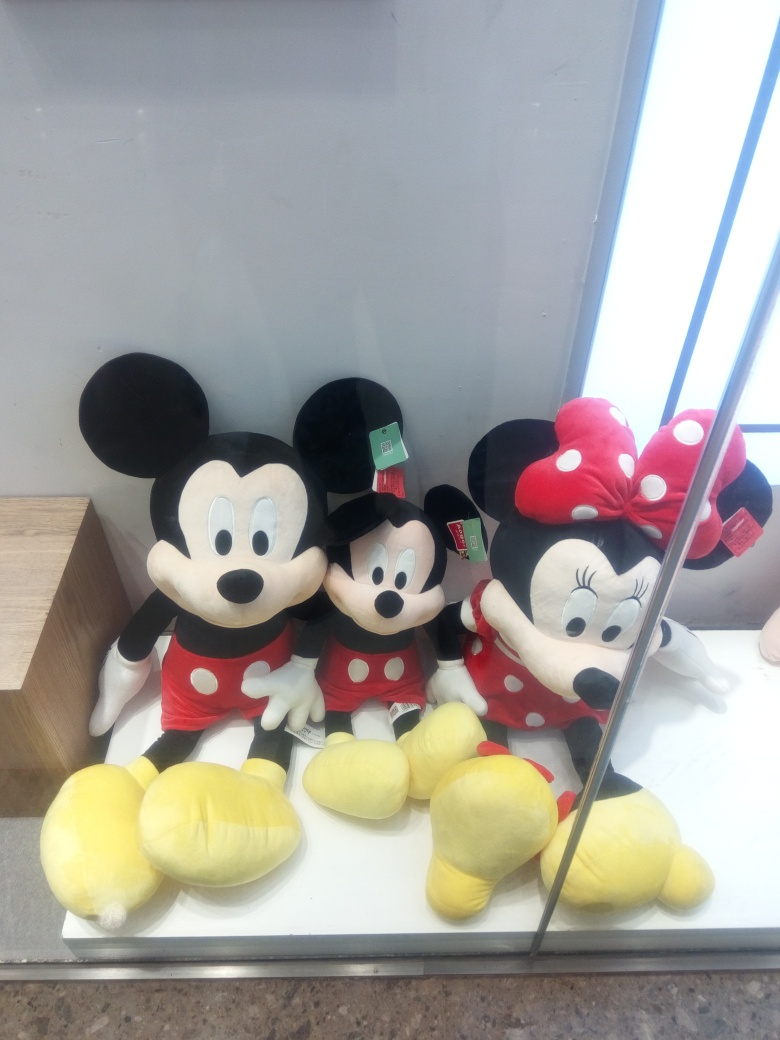Is the focus sharp in the photo?
 Yes 